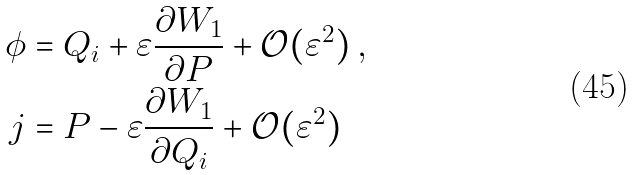Convert formula to latex. <formula><loc_0><loc_0><loc_500><loc_500>\phi & = Q _ { i } + \varepsilon \frac { \partial W _ { 1 } } { \partial P } + \mathcal { O } ( \varepsilon ^ { 2 } ) \, , \\ j & = P - \varepsilon \frac { \partial W _ { 1 } } { \partial Q _ { i } } + \mathcal { O } ( \varepsilon ^ { 2 } )</formula> 